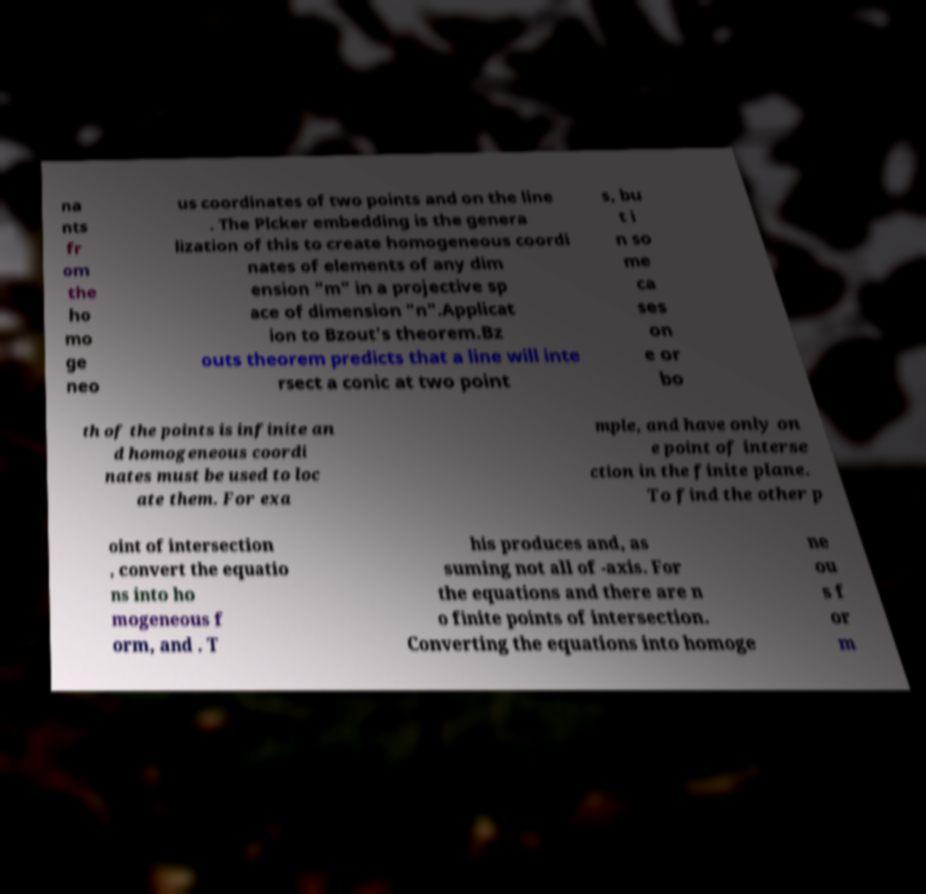Could you assist in decoding the text presented in this image and type it out clearly? na nts fr om the ho mo ge neo us coordinates of two points and on the line . The Plcker embedding is the genera lization of this to create homogeneous coordi nates of elements of any dim ension "m" in a projective sp ace of dimension "n".Applicat ion to Bzout's theorem.Bz outs theorem predicts that a line will inte rsect a conic at two point s, bu t i n so me ca ses on e or bo th of the points is infinite an d homogeneous coordi nates must be used to loc ate them. For exa mple, and have only on e point of interse ction in the finite plane. To find the other p oint of intersection , convert the equatio ns into ho mogeneous f orm, and . T his produces and, as suming not all of -axis. For the equations and there are n o finite points of intersection. Converting the equations into homoge ne ou s f or m 